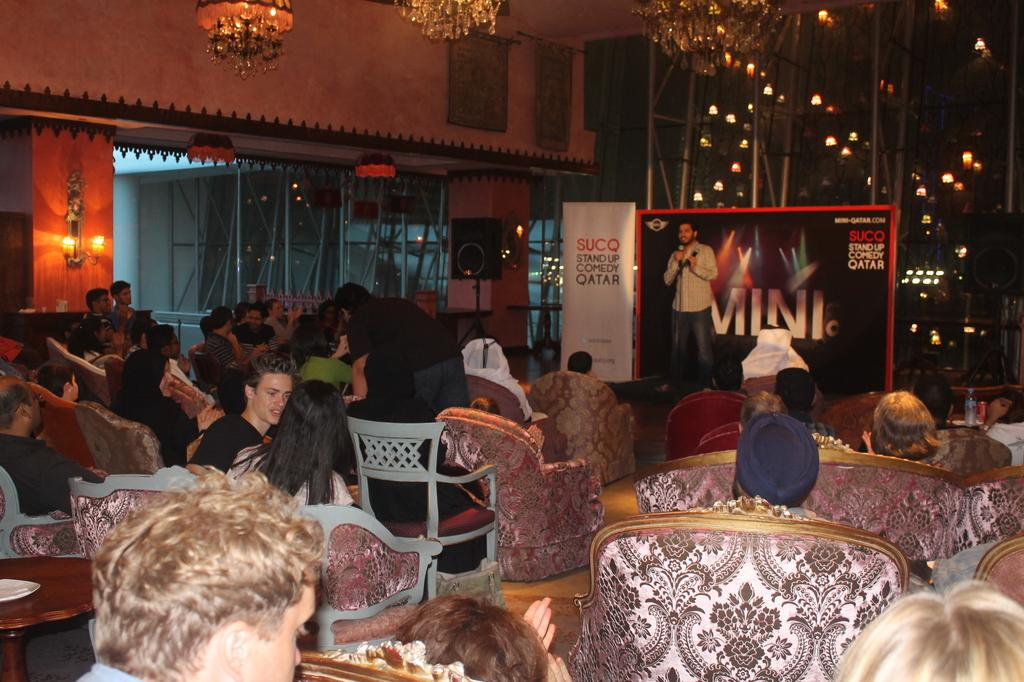What are the people in the image doing? The persons in the image are sitting on chairs. What else can be seen in the image besides the people sitting on chairs? There is a banner, a person standing in front of the banner holding a mic, and a speaker with a stand in the image. Can you describe the lighting in the image? There are lights visible in the distance. What type of doll is sitting on the can in the image? There is no doll or can present in the image. How many stars can be seen in the image? There are no stars visible in the image. 